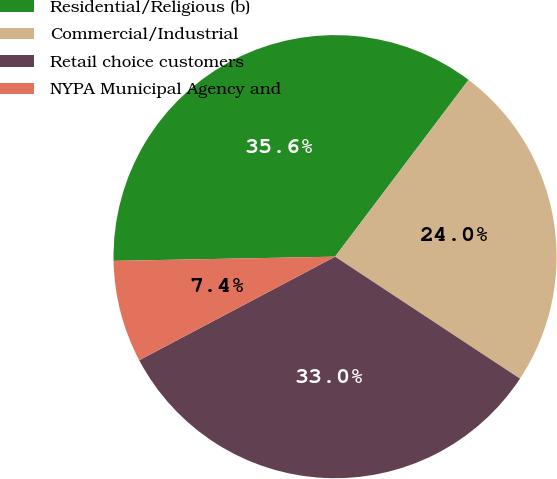Convert chart. <chart><loc_0><loc_0><loc_500><loc_500><pie_chart><fcel>Residential/Religious (b)<fcel>Commercial/Industrial<fcel>Retail choice customers<fcel>NYPA Municipal Agency and<nl><fcel>35.6%<fcel>23.99%<fcel>32.98%<fcel>7.44%<nl></chart> 